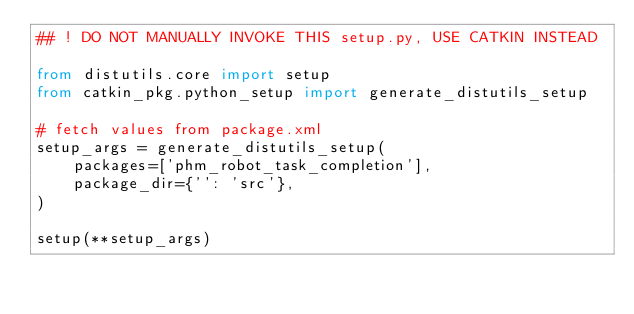<code> <loc_0><loc_0><loc_500><loc_500><_Python_>## ! DO NOT MANUALLY INVOKE THIS setup.py, USE CATKIN INSTEAD

from distutils.core import setup
from catkin_pkg.python_setup import generate_distutils_setup

# fetch values from package.xml
setup_args = generate_distutils_setup(
    packages=['phm_robot_task_completion'],
    package_dir={'': 'src'},
)

setup(**setup_args)
</code> 